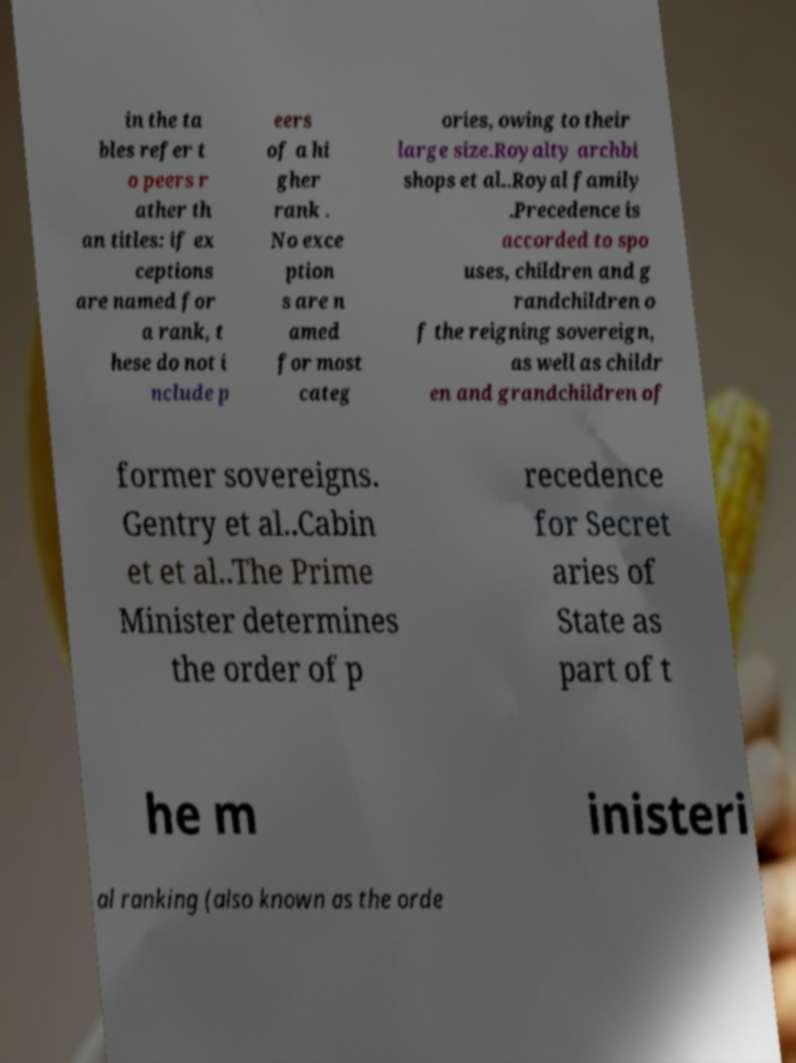Could you assist in decoding the text presented in this image and type it out clearly? in the ta bles refer t o peers r ather th an titles: if ex ceptions are named for a rank, t hese do not i nclude p eers of a hi gher rank . No exce ption s are n amed for most categ ories, owing to their large size.Royalty archbi shops et al..Royal family .Precedence is accorded to spo uses, children and g randchildren o f the reigning sovereign, as well as childr en and grandchildren of former sovereigns. Gentry et al..Cabin et et al..The Prime Minister determines the order of p recedence for Secret aries of State as part of t he m inisteri al ranking (also known as the orde 